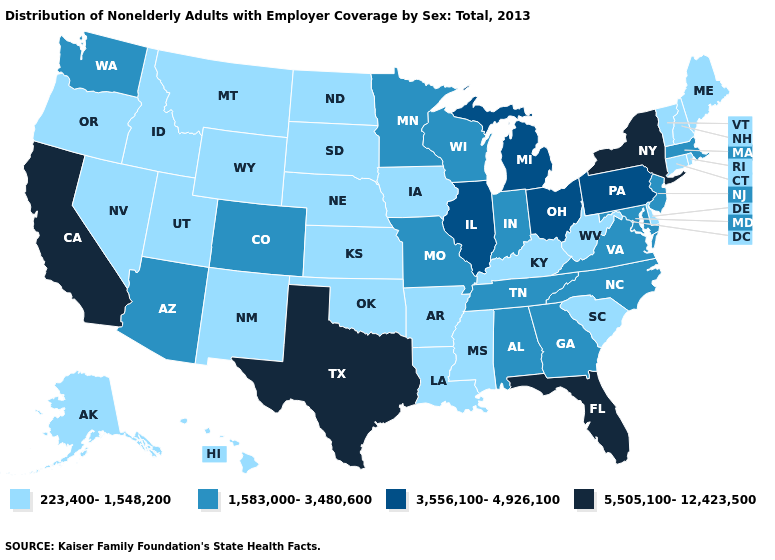Which states have the highest value in the USA?
Quick response, please. California, Florida, New York, Texas. Name the states that have a value in the range 5,505,100-12,423,500?
Quick response, please. California, Florida, New York, Texas. What is the lowest value in the MidWest?
Give a very brief answer. 223,400-1,548,200. Which states have the lowest value in the Northeast?
Concise answer only. Connecticut, Maine, New Hampshire, Rhode Island, Vermont. What is the highest value in states that border Illinois?
Write a very short answer. 1,583,000-3,480,600. Does Pennsylvania have the same value as Missouri?
Quick response, please. No. How many symbols are there in the legend?
Answer briefly. 4. What is the highest value in the USA?
Answer briefly. 5,505,100-12,423,500. Among the states that border New Mexico , which have the lowest value?
Concise answer only. Oklahoma, Utah. What is the highest value in the West ?
Keep it brief. 5,505,100-12,423,500. How many symbols are there in the legend?
Short answer required. 4. Does Wyoming have the highest value in the USA?
Write a very short answer. No. What is the value of Montana?
Concise answer only. 223,400-1,548,200. What is the highest value in states that border Iowa?
Answer briefly. 3,556,100-4,926,100. Does Florida have the highest value in the South?
Short answer required. Yes. 